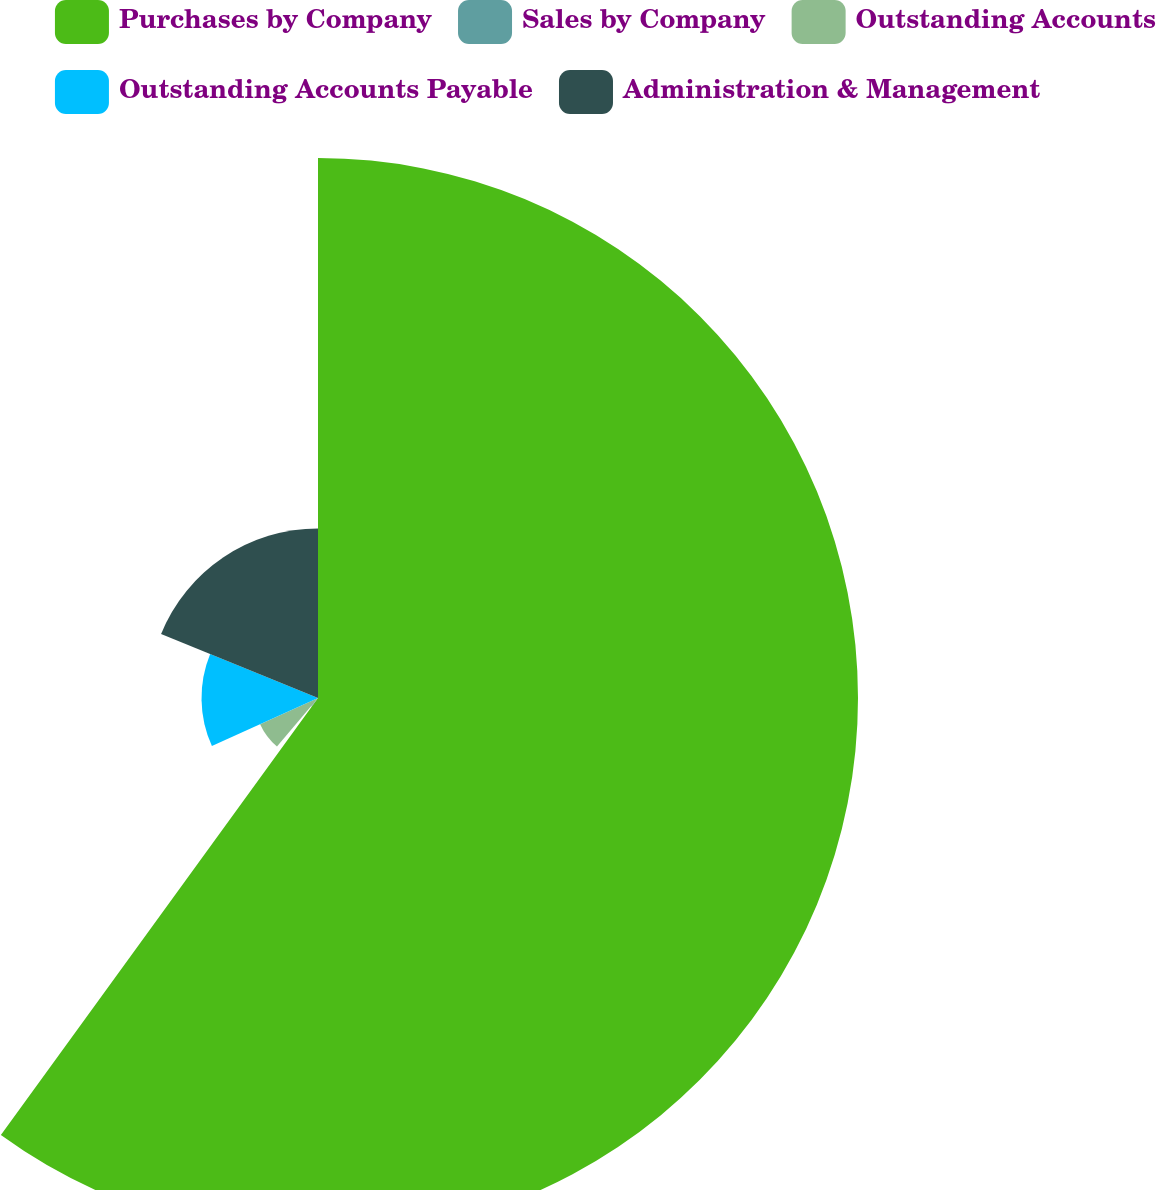<chart> <loc_0><loc_0><loc_500><loc_500><pie_chart><fcel>Purchases by Company<fcel>Sales by Company<fcel>Outstanding Accounts<fcel>Outstanding Accounts Payable<fcel>Administration & Management<nl><fcel>59.99%<fcel>1.18%<fcel>7.06%<fcel>12.94%<fcel>18.83%<nl></chart> 